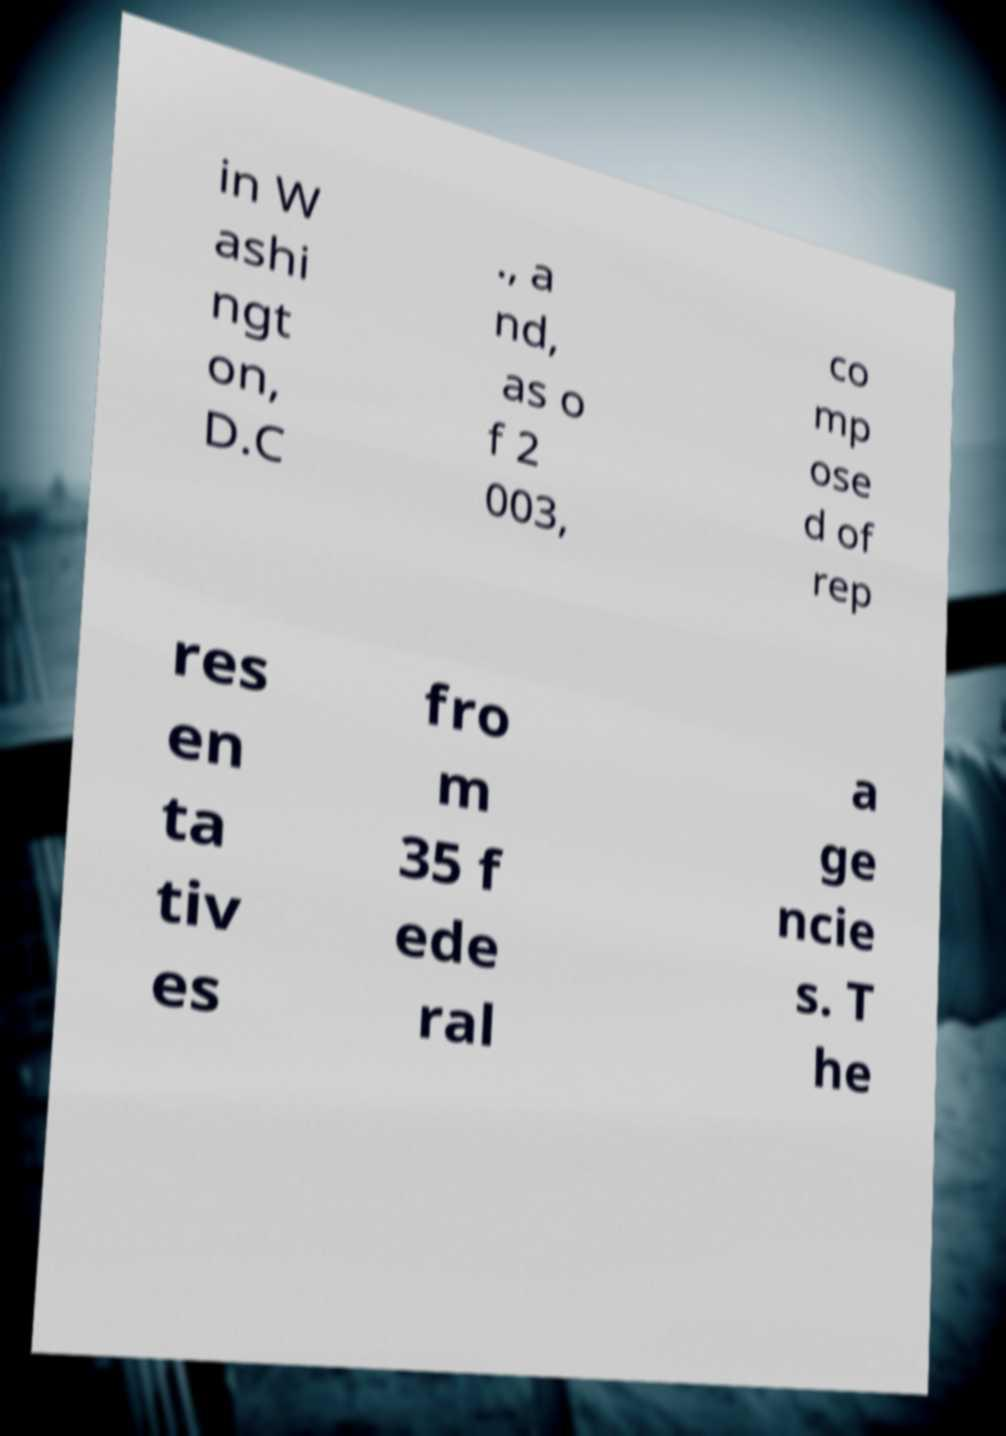Please read and relay the text visible in this image. What does it say? in W ashi ngt on, D.C ., a nd, as o f 2 003, co mp ose d of rep res en ta tiv es fro m 35 f ede ral a ge ncie s. T he 